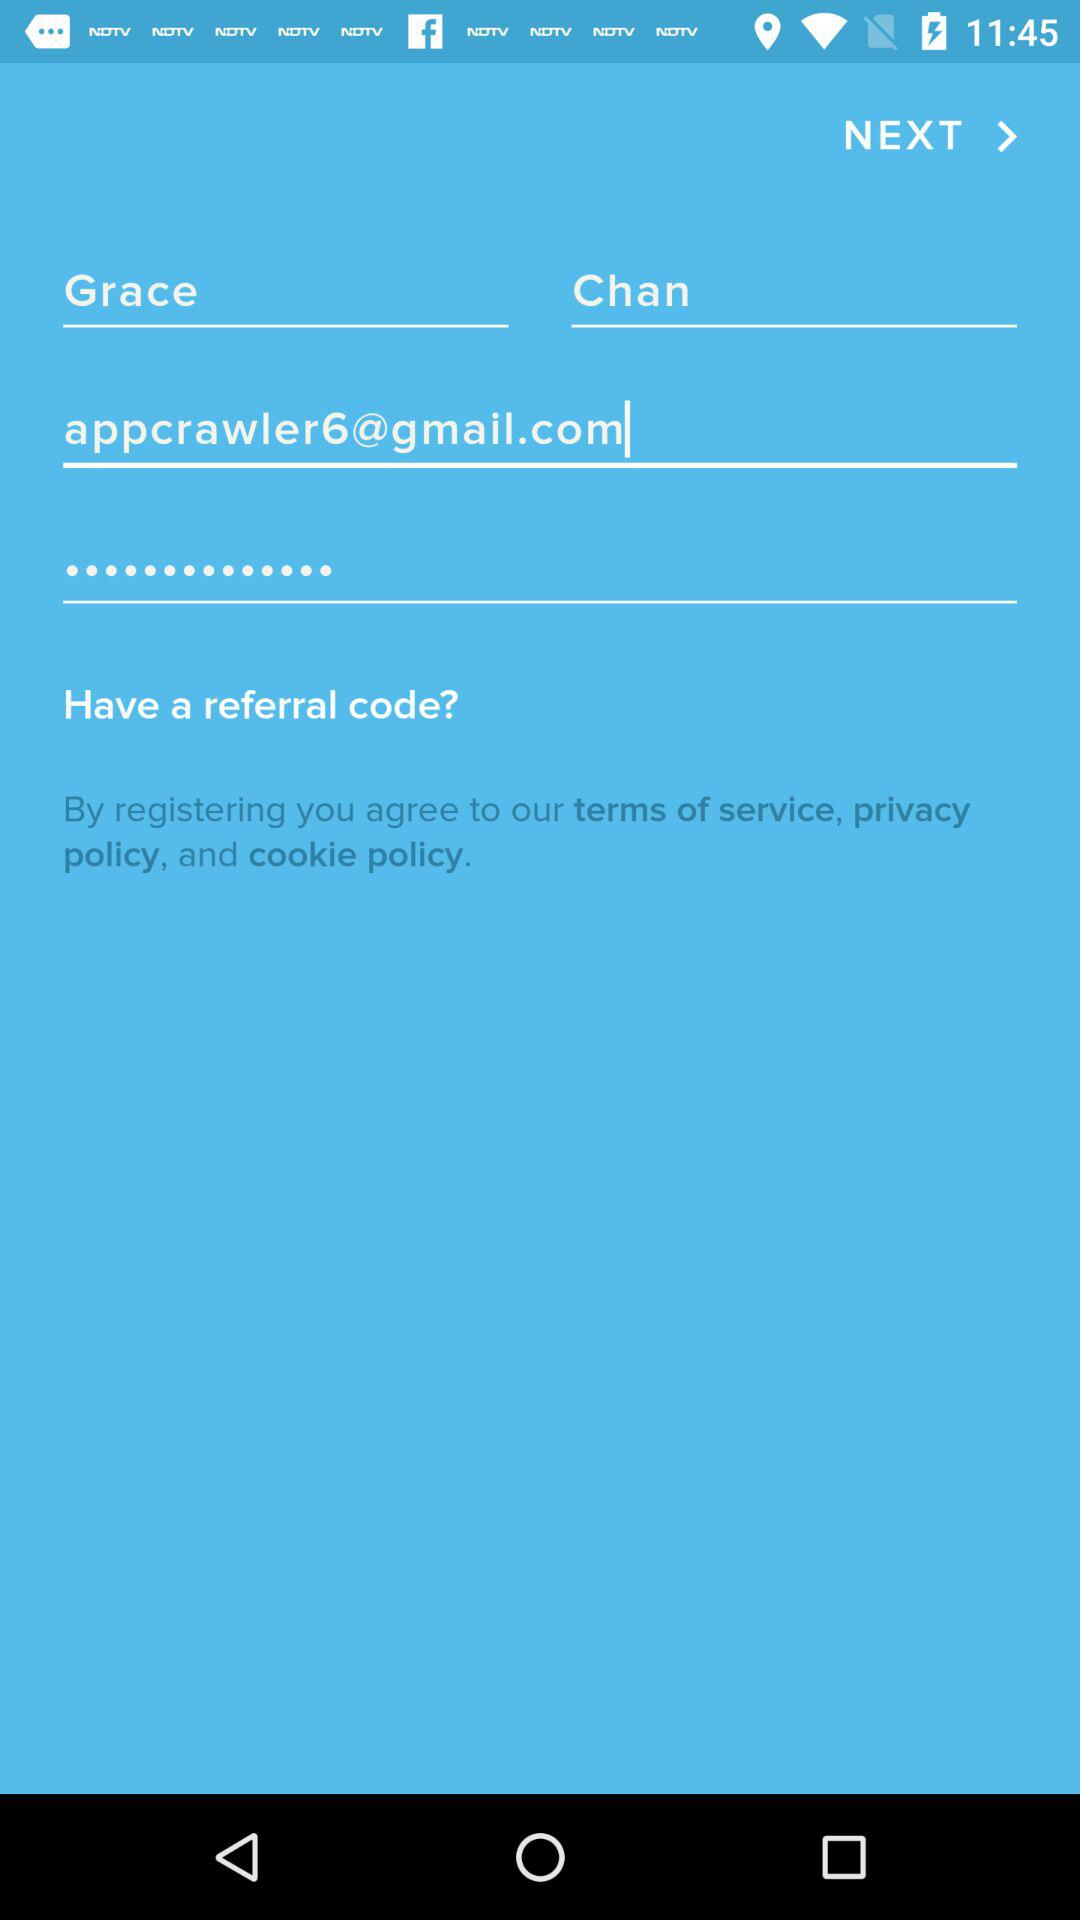What is the given email address? The email address is "appcrawler6@gmail.com". 